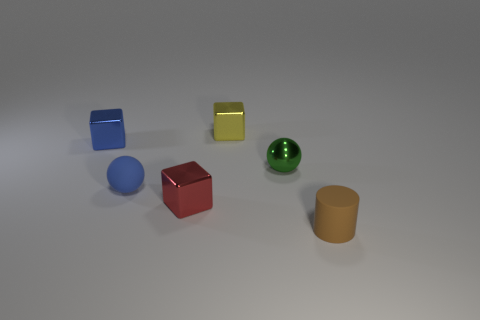Add 4 big gray metal blocks. How many objects exist? 10 Subtract all blue blocks. How many blocks are left? 2 Subtract all yellow blocks. How many blocks are left? 2 Subtract all blue spheres. Subtract all purple cylinders. How many spheres are left? 1 Subtract all cyan cylinders. How many green spheres are left? 1 Subtract all spheres. Subtract all big red rubber cylinders. How many objects are left? 4 Add 3 yellow blocks. How many yellow blocks are left? 4 Add 4 brown rubber cylinders. How many brown rubber cylinders exist? 5 Subtract 0 blue cylinders. How many objects are left? 6 Subtract all cylinders. How many objects are left? 5 